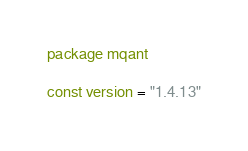<code> <loc_0><loc_0><loc_500><loc_500><_Go_>package mqant

const version = "1.4.13"
</code> 